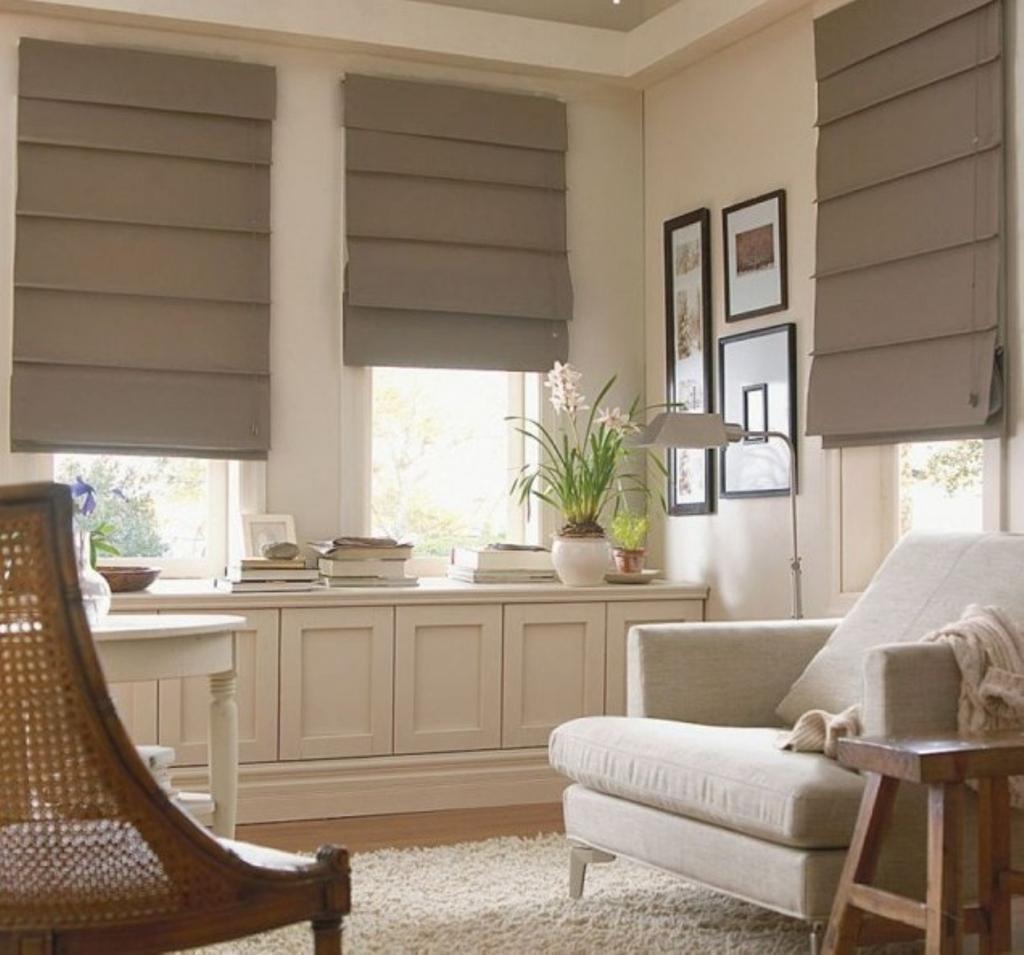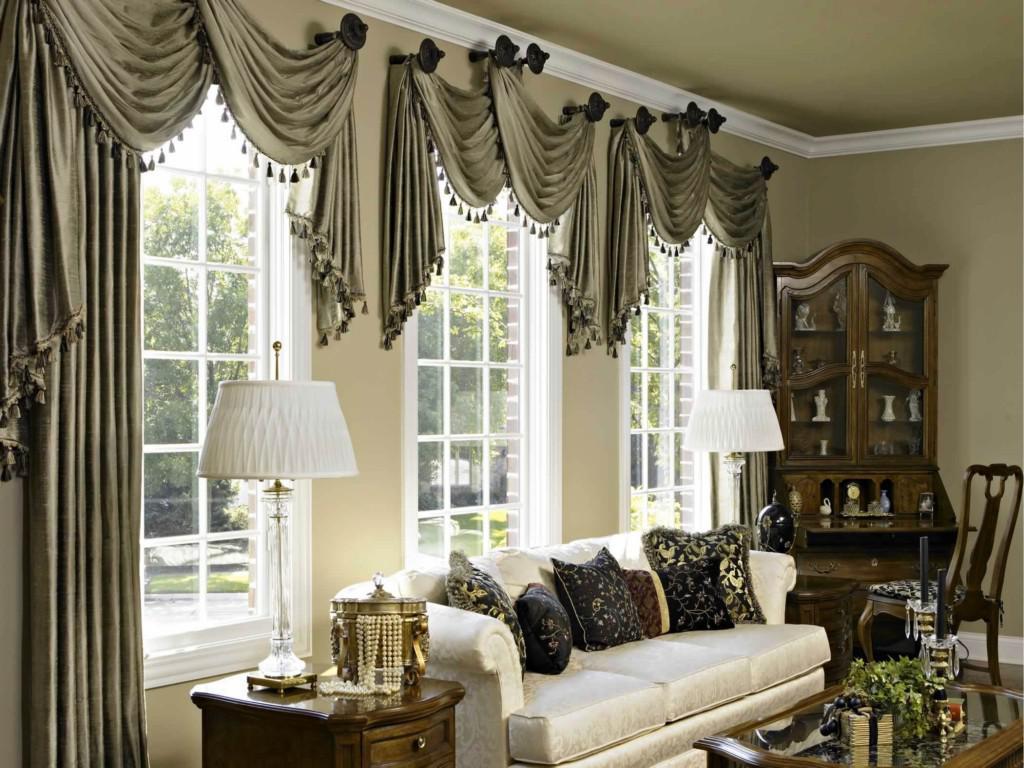The first image is the image on the left, the second image is the image on the right. For the images shown, is this caption "The couch in the right hand image is in front of a window with sunlight coming in." true? Answer yes or no. Yes. The first image is the image on the left, the second image is the image on the right. Analyze the images presented: Is the assertion "In at least one image there is a grey four seat sofa in front of three white open blinds." valid? Answer yes or no. No. 